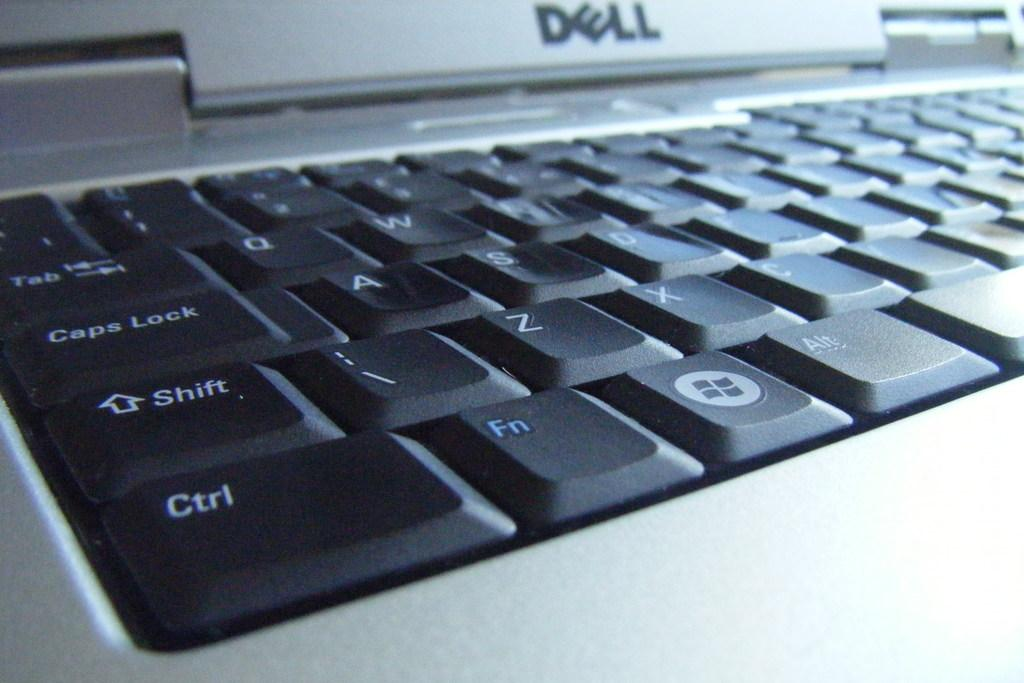Provide a one-sentence caption for the provided image. The Dell computer company manufactured the keyboard and computer.. 